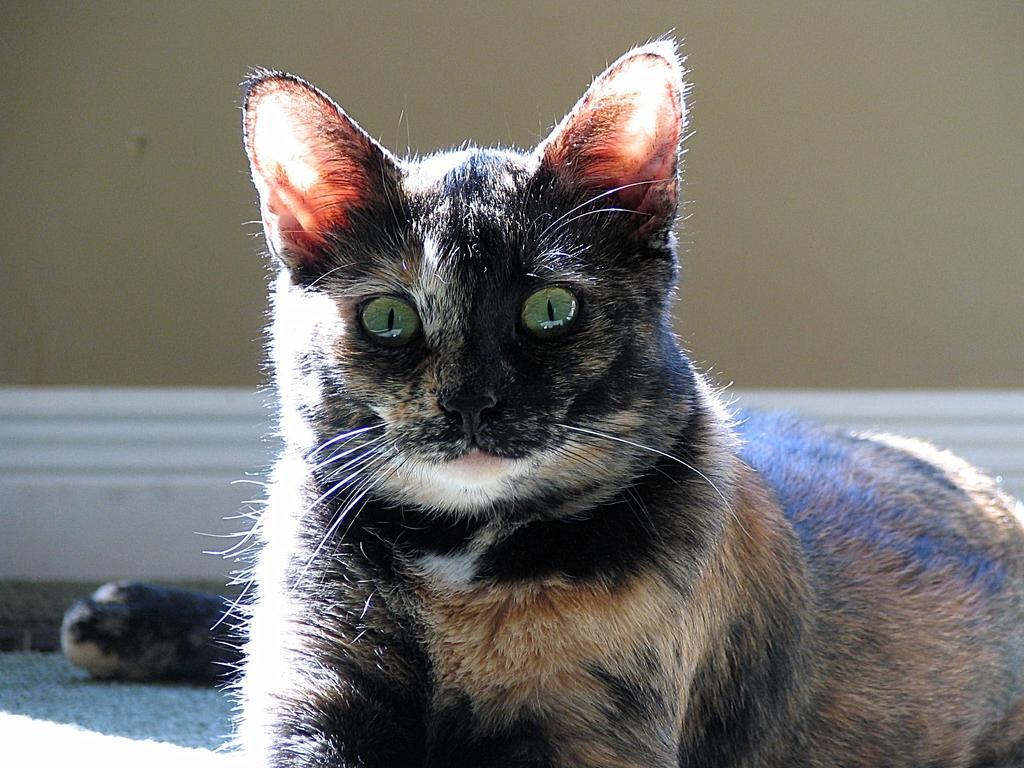Can you describe this image briefly? In this image, I can see a black cat sitting on the floor. This looks like a wall. 